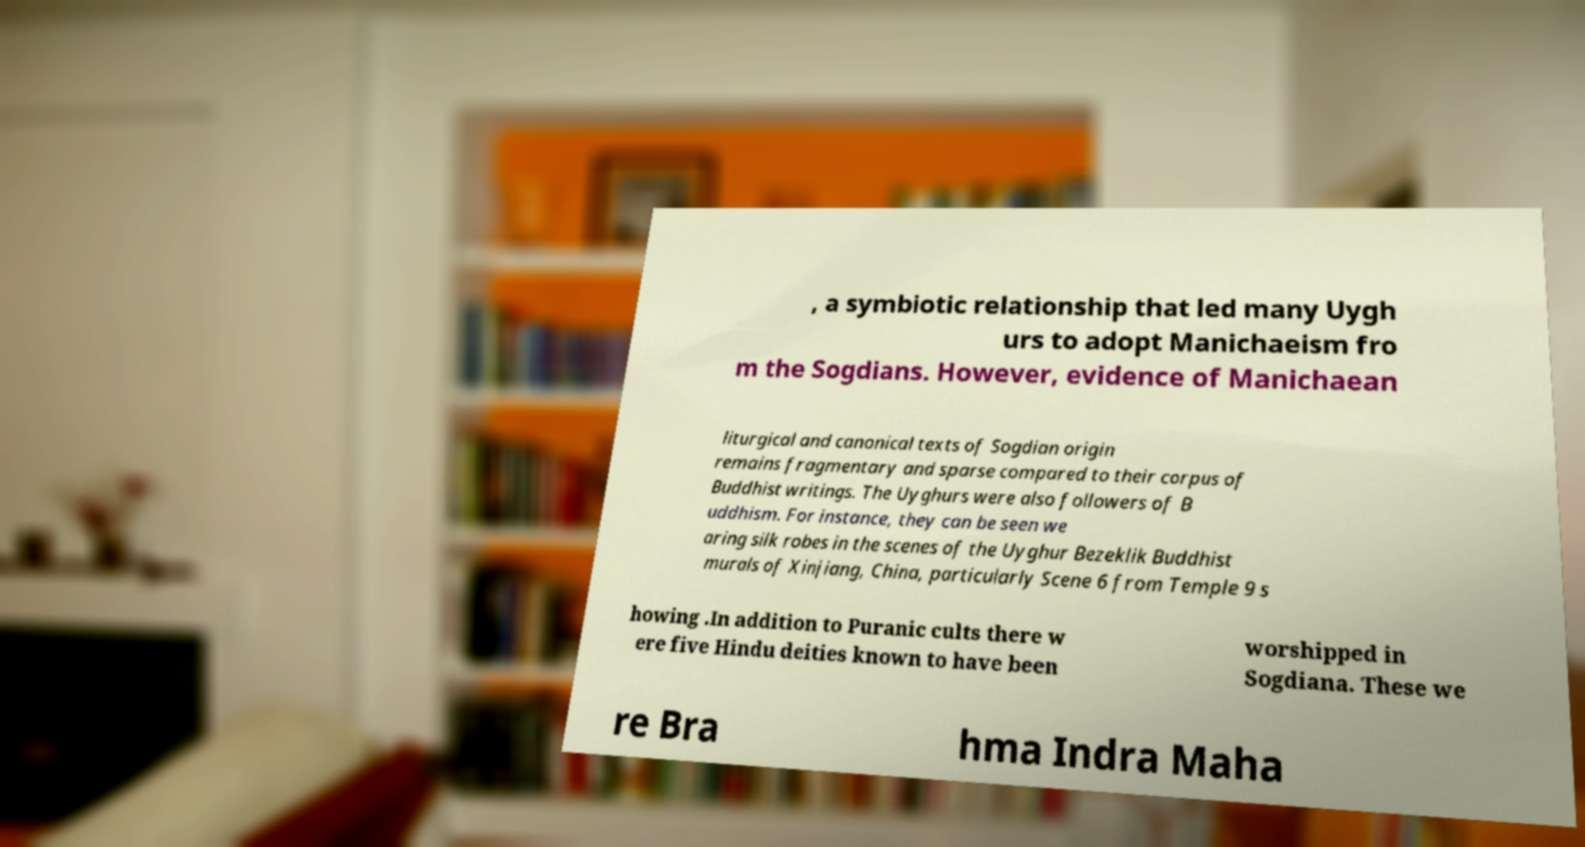For documentation purposes, I need the text within this image transcribed. Could you provide that? , a symbiotic relationship that led many Uygh urs to adopt Manichaeism fro m the Sogdians. However, evidence of Manichaean liturgical and canonical texts of Sogdian origin remains fragmentary and sparse compared to their corpus of Buddhist writings. The Uyghurs were also followers of B uddhism. For instance, they can be seen we aring silk robes in the scenes of the Uyghur Bezeklik Buddhist murals of Xinjiang, China, particularly Scene 6 from Temple 9 s howing .In addition to Puranic cults there w ere five Hindu deities known to have been worshipped in Sogdiana. These we re Bra hma Indra Maha 